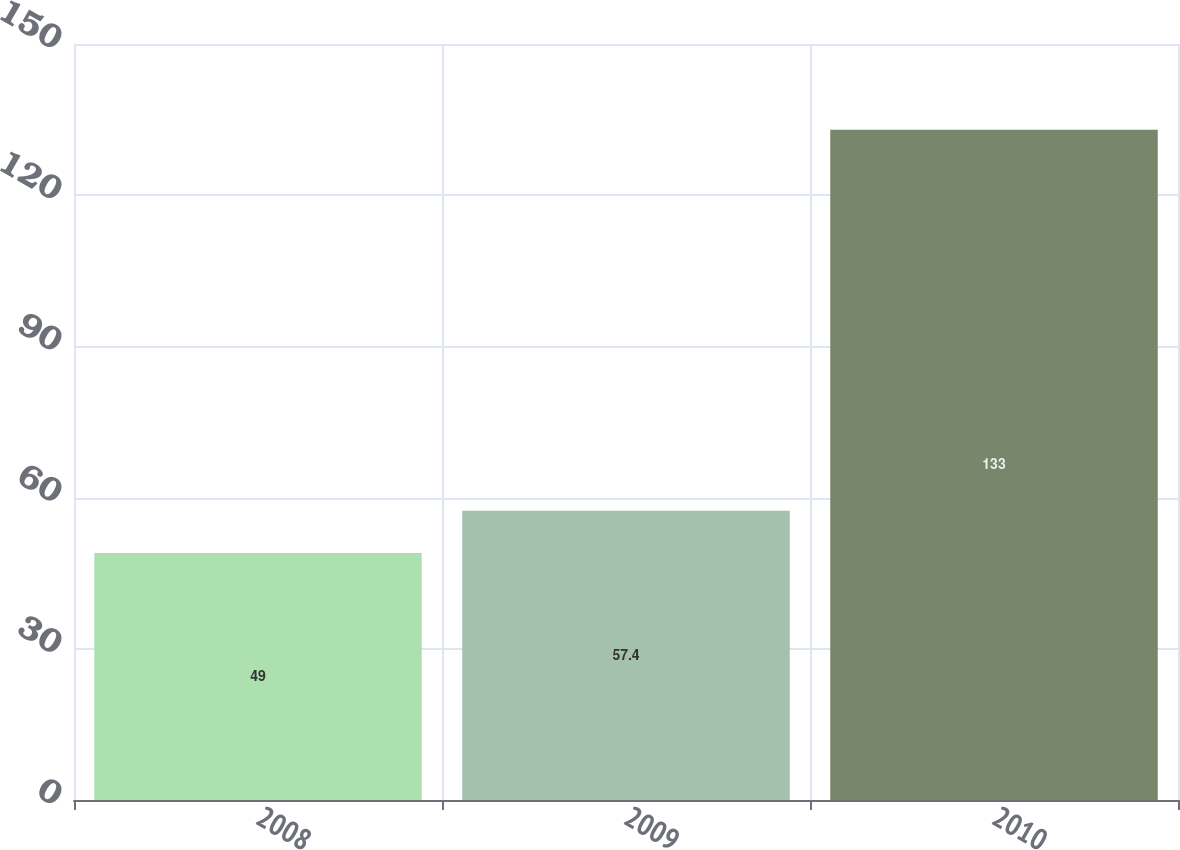Convert chart to OTSL. <chart><loc_0><loc_0><loc_500><loc_500><bar_chart><fcel>2008<fcel>2009<fcel>2010<nl><fcel>49<fcel>57.4<fcel>133<nl></chart> 